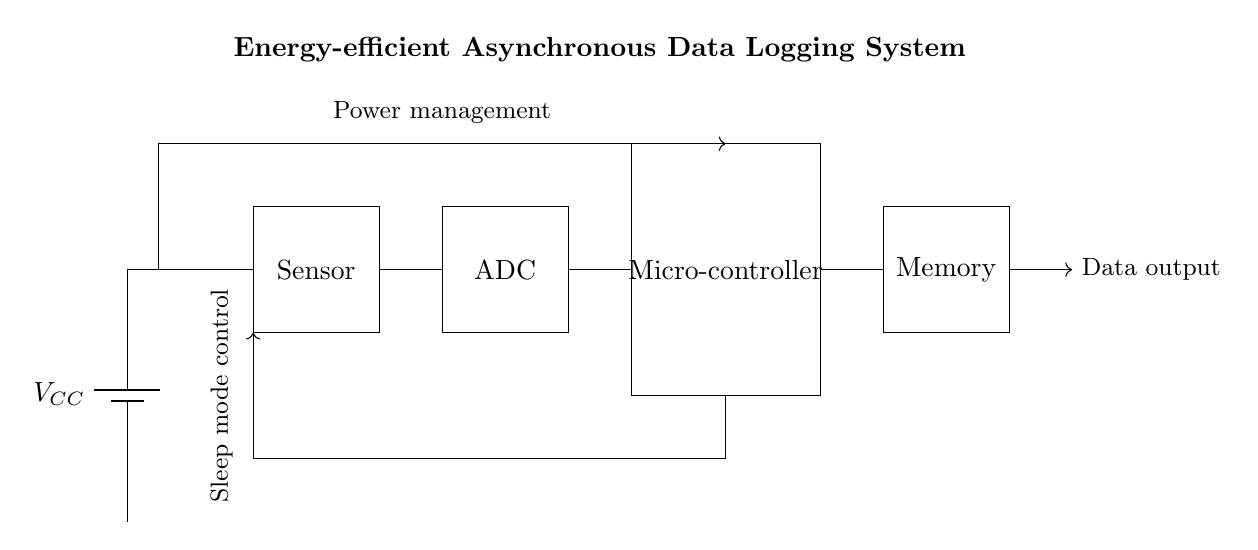What component is the power source? The power source in the circuit diagram is represented by a battery symbol, labeled as V_CC.
Answer: Battery What is the function of the ADC block? The ADC block, which stands for Analog to Digital Converter, converts analog signals from the sensor into digital signals that the microcontroller can process.
Answer: Conversion What is the role of the microcontroller in this circuit? The microcontroller processes the digital data from the ADC, controls the sleep mode, and handles communication with the memory block for data storage.
Answer: Processing What controls the sleep mode in the circuit? The sleep mode control is indicated by the vertical arrow connecting to both the microcontroller and the sensor block, which shows that the microcontroller manages the low-power state of the system.
Answer: Microcontroller How is power distributed to the components? The power management section is depicted with connections showing that power flows from the battery through the circuit, indicating all components receive power from V_CC.
Answer: V_CC What does the memory block do in this system? The memory block stores the digital data received from the microcontroller for future analysis and retrieval, indicating its purpose in the system.
Answer: Storage What type of data output does this circuit generate? The circuit outputs data processed by the microcontroller, as indicated by the arrow leaving the memory block labeled "Data output," which suggests the final processed results leave the system.
Answer: Processed data 